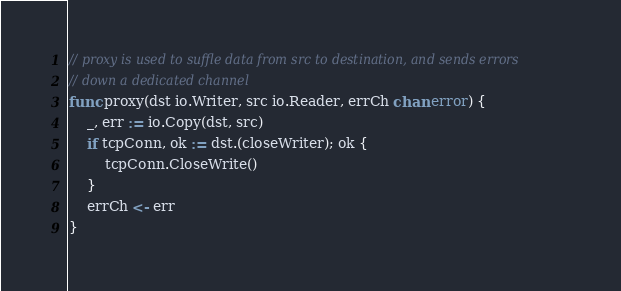Convert code to text. <code><loc_0><loc_0><loc_500><loc_500><_Go_>// proxy is used to suffle data from src to destination, and sends errors
// down a dedicated channel
func proxy(dst io.Writer, src io.Reader, errCh chan error) {
	_, err := io.Copy(dst, src)
	if tcpConn, ok := dst.(closeWriter); ok {
		tcpConn.CloseWrite()
	}
	errCh <- err
}
</code> 